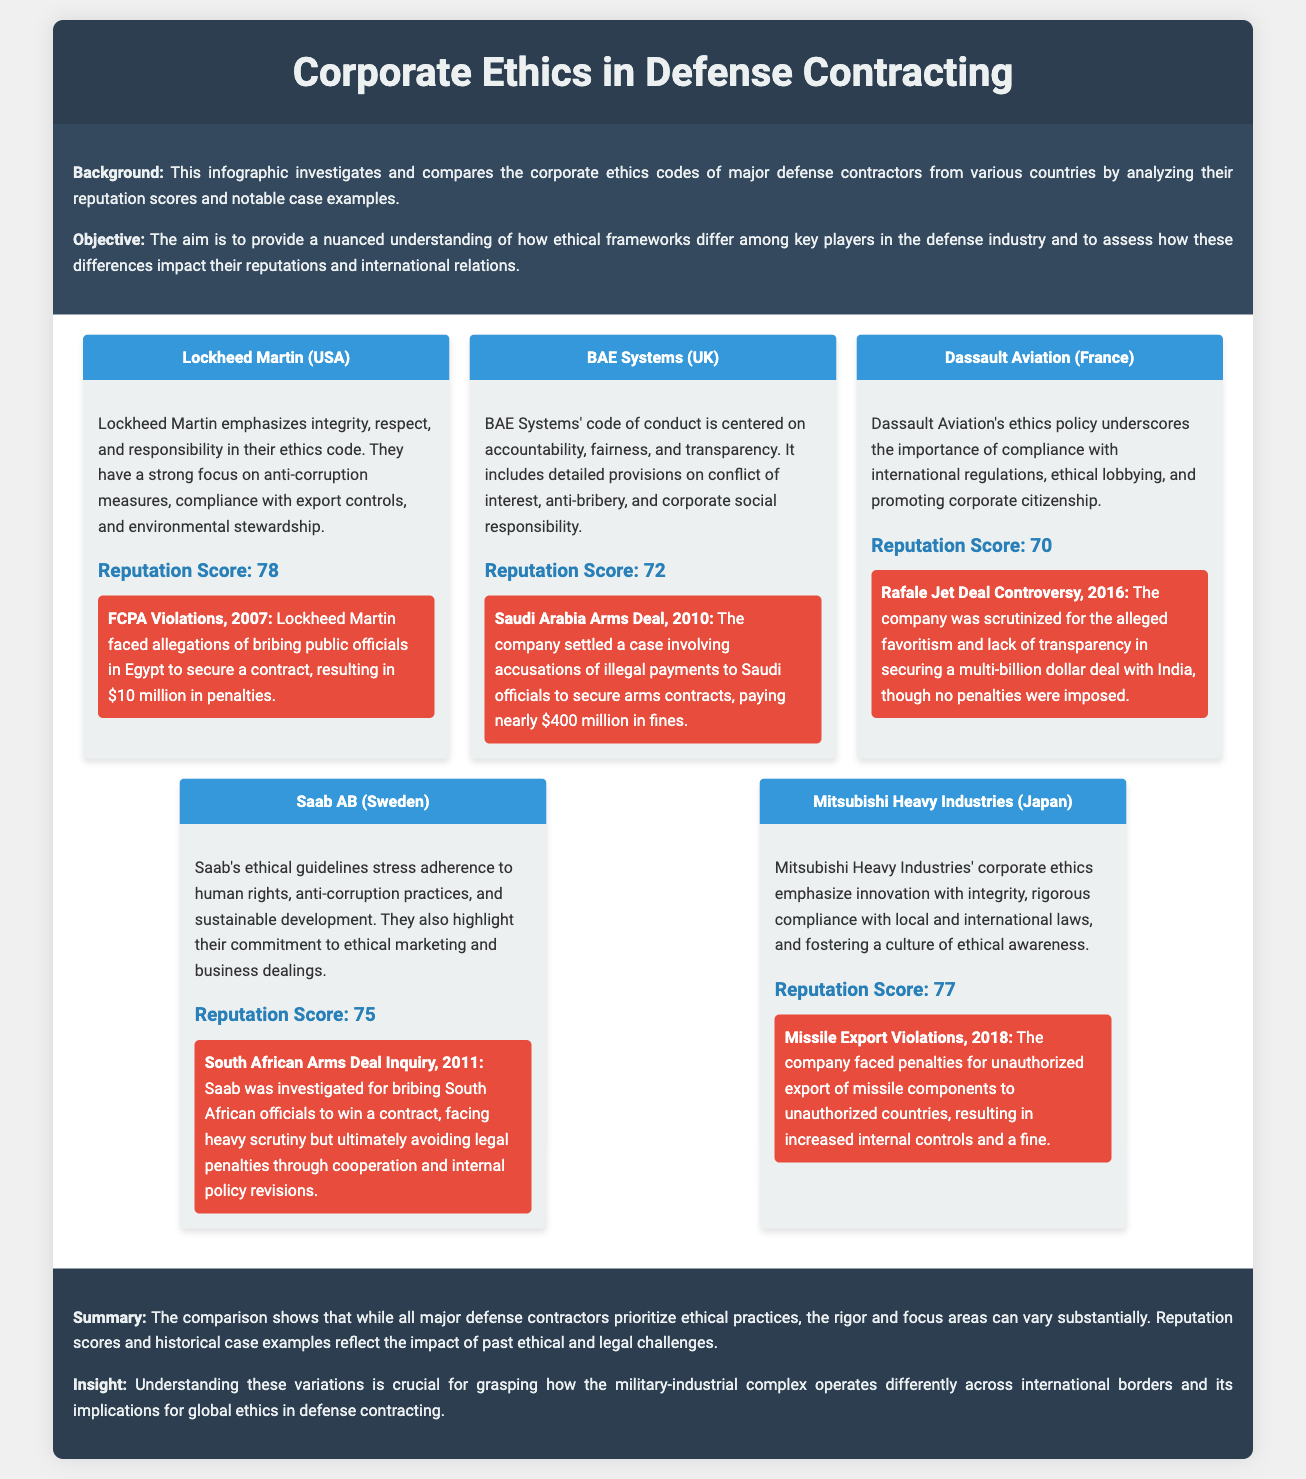What is the reputation score of Lockheed Martin? The reputation score for Lockheed Martin is explicitly stated in the document as 78.
Answer: 78 What type of violations did Lockheed Martin face in 2007? The document mentions that Lockheed Martin faced allegations of bribing public officials, categorized under FCPA Violations.
Answer: FCPA Violations Which company has a case involving the Saudi Arabia Arms Deal? The case of the Saudi Arabia Arms Deal is specifically associated with BAE Systems as noted in the document.
Answer: BAE Systems What is the main focus of Saab AB's ethical guidelines? Saab AB's ethical guidelines stress adherence to human rights as mentioned in the document.
Answer: Human rights What year did Mitsubishi Heavy Industries face missile export violations? The document states that Mitsubishi Heavy Industries faced missile export violations in the year 2018.
Answer: 2018 What are the three core values highlighted by Lockheed Martin in their ethics code? The core values highlighted by Lockheed Martin include integrity, respect, and responsibility as outlined in their ethics code.
Answer: Integrity, respect, responsibility Which company emphasizes innovation with integrity in their corporate ethics? The document explicitly identifies Mitsubishi Heavy Industries as the company emphasizing innovation with integrity.
Answer: Mitsubishi Heavy Industries Which company is associated with the Rafale Jet Deal controversy? The Rafale Jet Deal controversy is associated with Dassault Aviation, as noted in the document.
Answer: Dassault Aviation What was the penalty for BAE Systems in the Saudi Arabia Arms Deal case? The document specifies that BAE Systems paid nearly $400 million in fines related to the Saudi Arabia Arms Deal case.
Answer: $400 million 